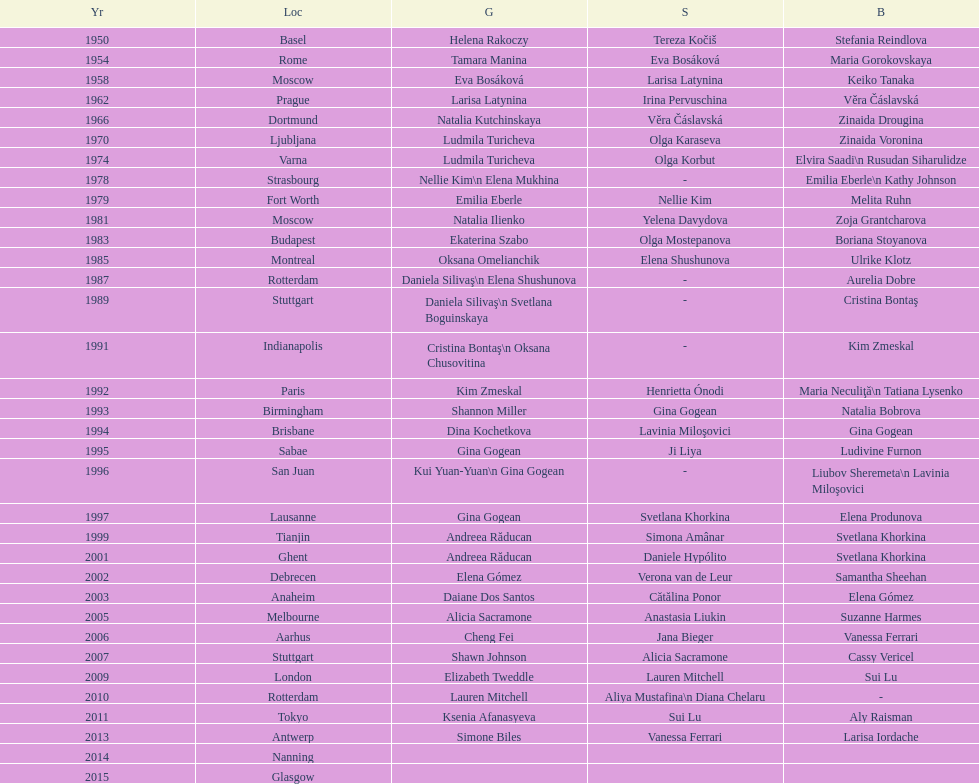Where did the world artistic gymnastics take place before san juan? Sabae. 